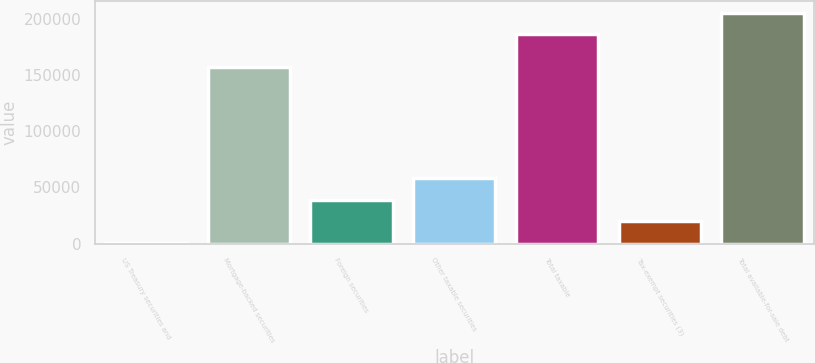Convert chart to OTSL. <chart><loc_0><loc_0><loc_500><loc_500><bar_chart><fcel>US Treasury securities and<fcel>Mortgage-backed securities<fcel>Foreign securities<fcel>Other taxable securities<fcel>Total taxable<fcel>Tax-exempt securities (3)<fcel>Total available-for-sale debt<nl><fcel>688<fcel>156893<fcel>39111.6<fcel>58323.4<fcel>186283<fcel>19899.8<fcel>205495<nl></chart> 